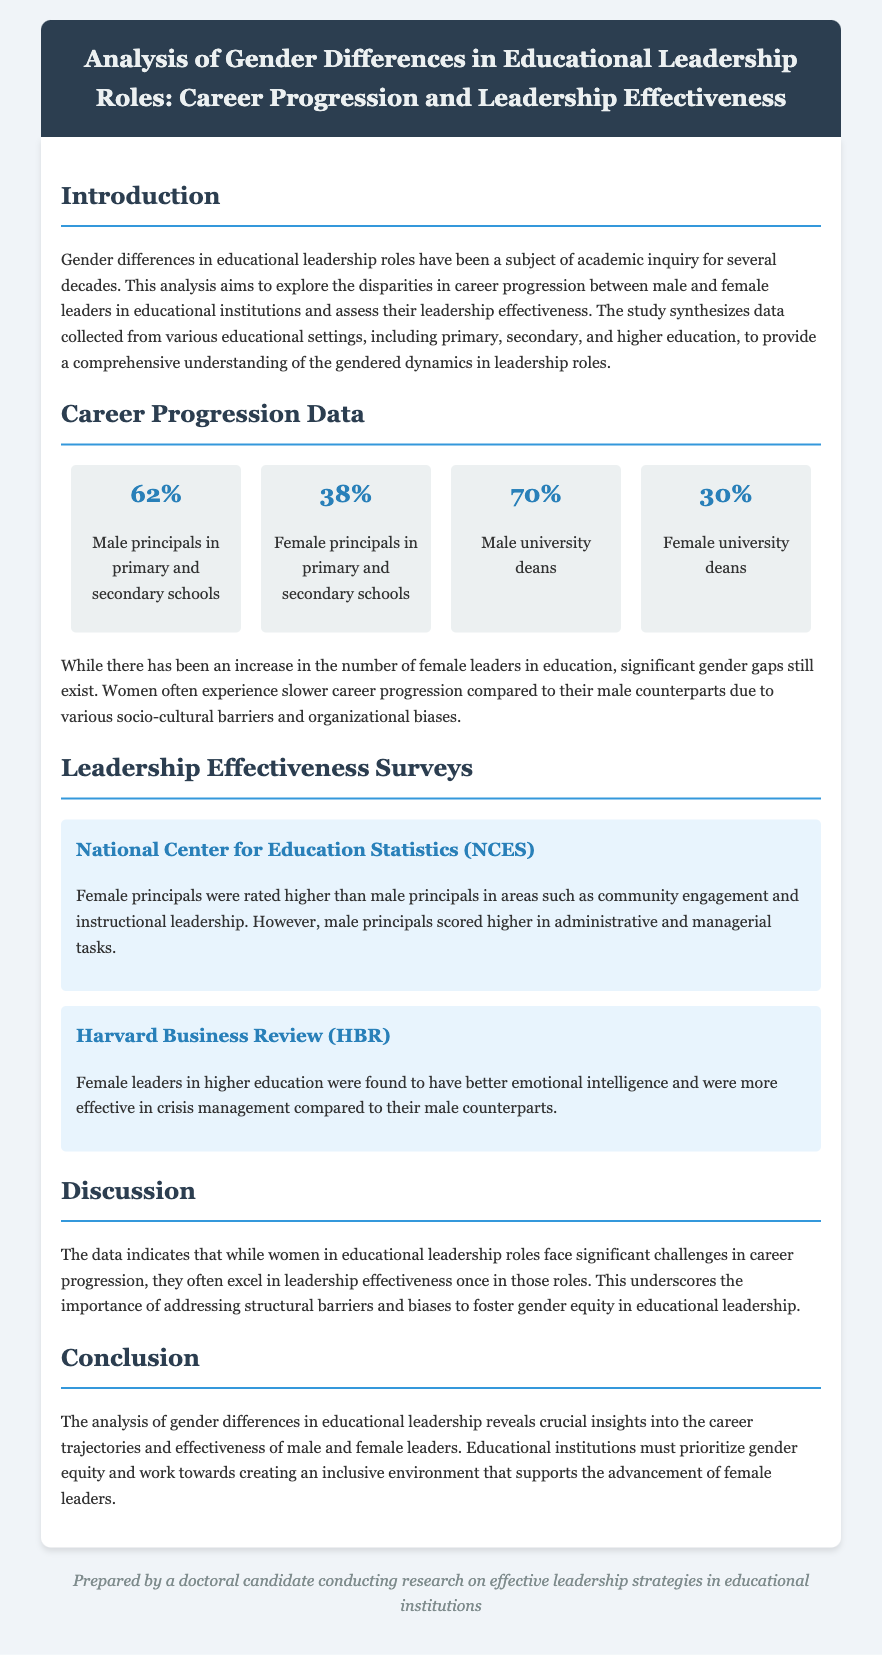What percentage of male principals are in primary and secondary schools? The document states that 62% of principals in primary and secondary schools are male.
Answer: 62% What percentage of female university deans are there? The document indicates that 30% of university deans are female.
Answer: 30% Which research body rated female principals higher in community engagement? The National Center for Education Statistics (NCES) rated female principals higher in this area.
Answer: NCES What trait did female leaders in higher education excel in according to the Harvard Business Review? Female leaders were found to have better emotional intelligence compared to male leaders.
Answer: Emotional intelligence What is one barrier faced by women in career progression in educational leadership? The document mentions socio-cultural barriers as one reason behind slower career progression for women.
Answer: Socio-cultural barriers What overall conclusion does the analysis reach regarding gender differences in educational leadership? The conclusion emphasizes the need to prioritize gender equity and create an inclusive environment for female leaders.
Answer: Gender equity What percentage of female principals exists in primary and secondary schools? According to the data, 38% of principals in primary and secondary schools are female.
Answer: 38% In which area did male principals score higher than female principals? Male principals scored higher in administrative and managerial tasks according to the survey data.
Answer: Administrative and managerial tasks 